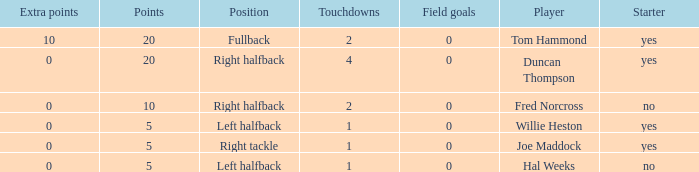What is the highest field goals when there were more than 1 touchdown and 0 extra points? 0.0. 